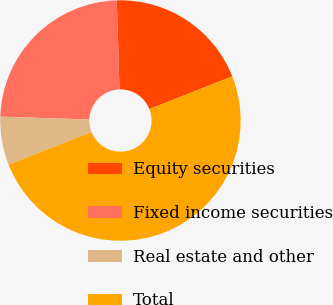<chart> <loc_0><loc_0><loc_500><loc_500><pie_chart><fcel>Equity securities<fcel>Fixed income securities<fcel>Real estate and other<fcel>Total<nl><fcel>19.5%<fcel>24.0%<fcel>6.5%<fcel>50.0%<nl></chart> 